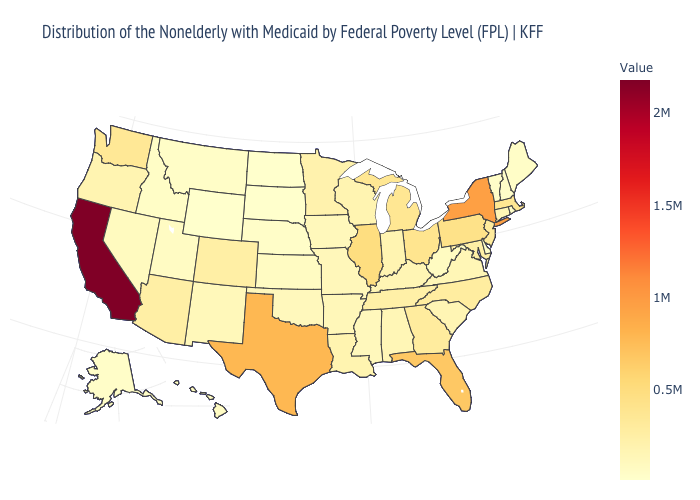Among the states that border Vermont , does New Hampshire have the lowest value?
Keep it brief. Yes. Which states have the lowest value in the USA?
Concise answer only. North Dakota. Does North Carolina have a lower value than New York?
Short answer required. Yes. Among the states that border Mississippi , does Arkansas have the lowest value?
Keep it brief. Yes. 